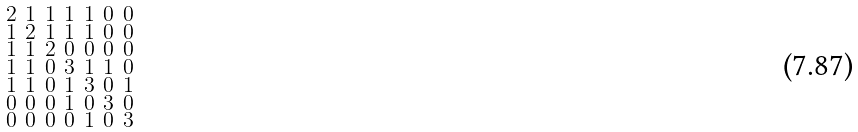<formula> <loc_0><loc_0><loc_500><loc_500>\begin{smallmatrix} 2 & 1 & 1 & 1 & 1 & 0 & 0 \\ 1 & 2 & 1 & 1 & 1 & 0 & 0 \\ 1 & 1 & 2 & 0 & 0 & 0 & 0 \\ 1 & 1 & 0 & 3 & 1 & 1 & 0 \\ 1 & 1 & 0 & 1 & 3 & 0 & 1 \\ 0 & 0 & 0 & 1 & 0 & 3 & 0 \\ 0 & 0 & 0 & 0 & 1 & 0 & 3 \end{smallmatrix}</formula> 